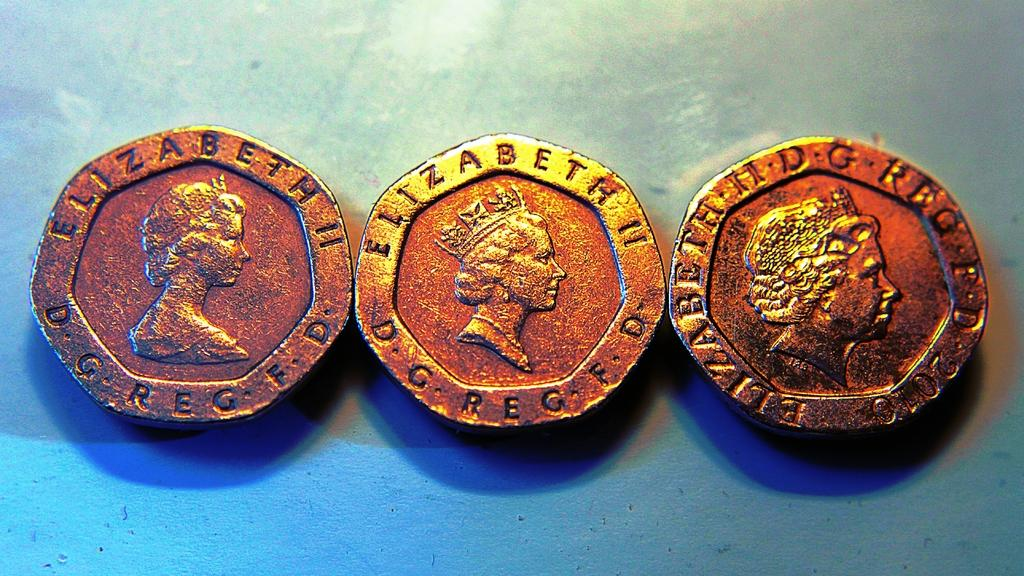How many coins are present in the image? There are three coins in the image. What is depicted on each coin? Each coin has a picture of a woman, identified as Elizabeth II. What is visible at the bottom of the image? There is a wall visible at the bottom of the image. How many spiders are crawling on the coins in the image? There are no spiders present in the image; it only features three coins with a picture of Elizabeth II. What is the name of the son of the woman depicted on the coins? The woman depicted on the coins is Elizabeth II, who does not have a son. 